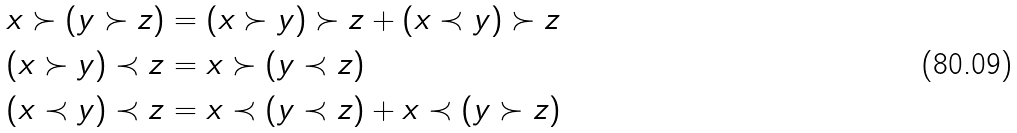<formula> <loc_0><loc_0><loc_500><loc_500>x \succ ( y \succ z ) & = ( x \succ y ) \succ z + ( x \prec y ) \succ z \\ ( x \succ y ) \prec z & = x \succ ( y \prec z ) \\ ( x \prec y ) \prec z & = x \prec ( y \prec z ) + x \prec ( y \succ z )</formula> 